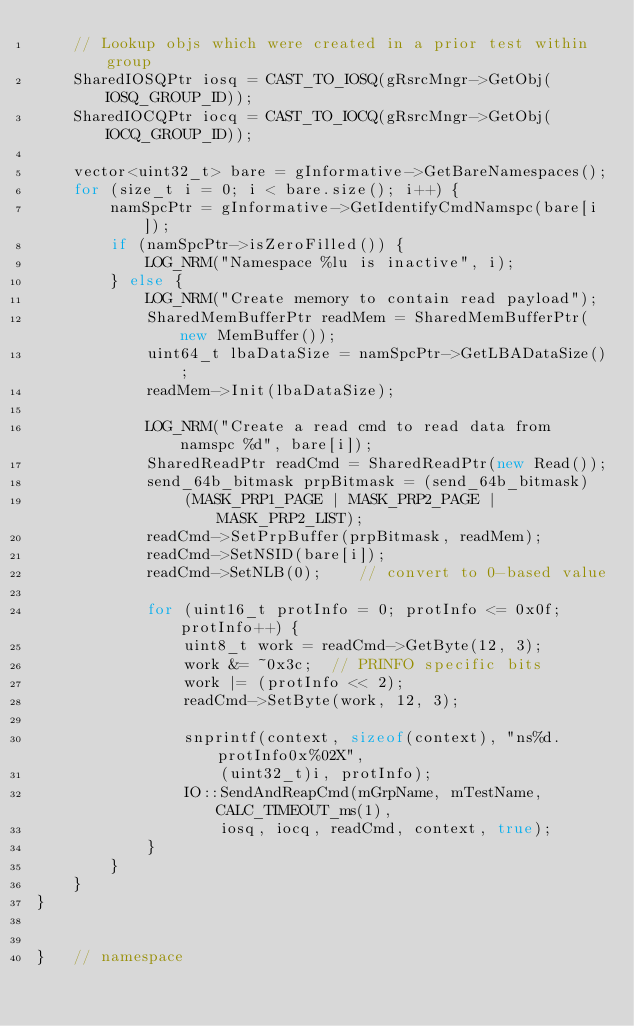Convert code to text. <code><loc_0><loc_0><loc_500><loc_500><_C++_>    // Lookup objs which were created in a prior test within group
    SharedIOSQPtr iosq = CAST_TO_IOSQ(gRsrcMngr->GetObj(IOSQ_GROUP_ID));
    SharedIOCQPtr iocq = CAST_TO_IOCQ(gRsrcMngr->GetObj(IOCQ_GROUP_ID));

    vector<uint32_t> bare = gInformative->GetBareNamespaces();
    for (size_t i = 0; i < bare.size(); i++) {
        namSpcPtr = gInformative->GetIdentifyCmdNamspc(bare[i]);
        if (namSpcPtr->isZeroFilled()) {
            LOG_NRM("Namespace %lu is inactive", i);
        } else {
            LOG_NRM("Create memory to contain read payload");
            SharedMemBufferPtr readMem = SharedMemBufferPtr(new MemBuffer());
            uint64_t lbaDataSize = namSpcPtr->GetLBADataSize();
            readMem->Init(lbaDataSize);

            LOG_NRM("Create a read cmd to read data from namspc %d", bare[i]);
            SharedReadPtr readCmd = SharedReadPtr(new Read());
            send_64b_bitmask prpBitmask = (send_64b_bitmask)
                (MASK_PRP1_PAGE | MASK_PRP2_PAGE | MASK_PRP2_LIST);
            readCmd->SetPrpBuffer(prpBitmask, readMem);
            readCmd->SetNSID(bare[i]);
            readCmd->SetNLB(0);    // convert to 0-based value

            for (uint16_t protInfo = 0; protInfo <= 0x0f; protInfo++) {
                uint8_t work = readCmd->GetByte(12, 3);
                work &= ~0x3c;  // PRINFO specific bits
                work |= (protInfo << 2);
                readCmd->SetByte(work, 12, 3);

                snprintf(context, sizeof(context), "ns%d.protInfo0x%02X",
                    (uint32_t)i, protInfo);
                IO::SendAndReapCmd(mGrpName, mTestName, CALC_TIMEOUT_ms(1),
                    iosq, iocq, readCmd, context, true);
            }
        }
    }
}


}   // namespace
</code> 